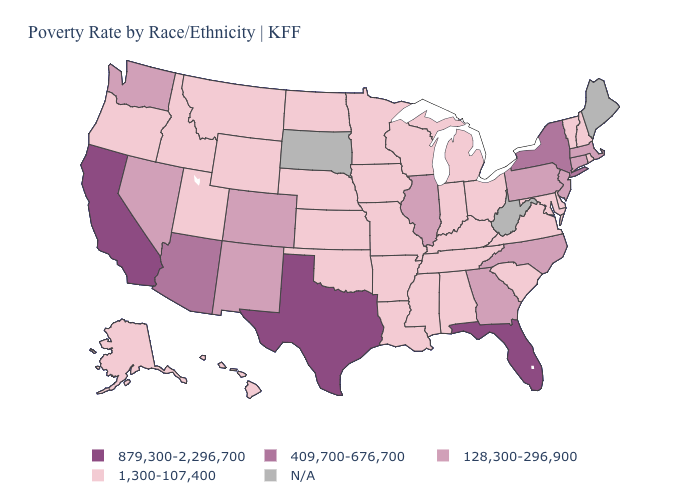Which states have the highest value in the USA?
Answer briefly. California, Florida, Texas. What is the value of Massachusetts?
Keep it brief. 128,300-296,900. Among the states that border Nevada , which have the lowest value?
Quick response, please. Idaho, Oregon, Utah. Does Iowa have the lowest value in the MidWest?
Write a very short answer. Yes. Name the states that have a value in the range 879,300-2,296,700?
Give a very brief answer. California, Florida, Texas. Name the states that have a value in the range 409,700-676,700?
Short answer required. Arizona, New York. Name the states that have a value in the range 128,300-296,900?
Be succinct. Colorado, Connecticut, Georgia, Illinois, Massachusetts, Nevada, New Jersey, New Mexico, North Carolina, Pennsylvania, Washington. Does Texas have the highest value in the South?
Answer briefly. Yes. What is the value of Arkansas?
Short answer required. 1,300-107,400. What is the value of Tennessee?
Quick response, please. 1,300-107,400. What is the value of Nebraska?
Short answer required. 1,300-107,400. Which states have the highest value in the USA?
Concise answer only. California, Florida, Texas. Which states have the lowest value in the MidWest?
Give a very brief answer. Indiana, Iowa, Kansas, Michigan, Minnesota, Missouri, Nebraska, North Dakota, Ohio, Wisconsin. Name the states that have a value in the range 1,300-107,400?
Keep it brief. Alabama, Alaska, Arkansas, Delaware, Hawaii, Idaho, Indiana, Iowa, Kansas, Kentucky, Louisiana, Maryland, Michigan, Minnesota, Mississippi, Missouri, Montana, Nebraska, New Hampshire, North Dakota, Ohio, Oklahoma, Oregon, Rhode Island, South Carolina, Tennessee, Utah, Vermont, Virginia, Wisconsin, Wyoming. 